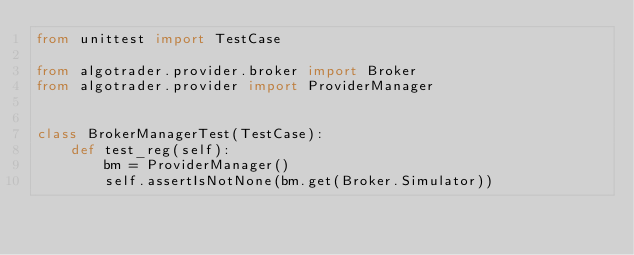<code> <loc_0><loc_0><loc_500><loc_500><_Python_>from unittest import TestCase

from algotrader.provider.broker import Broker
from algotrader.provider import ProviderManager


class BrokerManagerTest(TestCase):
    def test_reg(self):
        bm = ProviderManager()
        self.assertIsNotNone(bm.get(Broker.Simulator))
</code> 